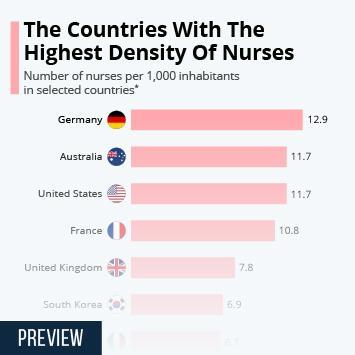Which country has the fifth highest density of Nurses per 1,000 inhabitants?
Answer the question with a short phrase. South Korea Which country has the highest density of Nurses per 1,000 inhabitants? Germany Which country share the second highest density of Nurses per 1,000 inhabitants along with United States? Australia Which country has the fourth highest density of Nurses per 1,000 inhabitants? United Kingdom Which two countries share the second highest density of Nurses per 1,000 inhabitants? Australia, United States Which country has the third highest density of Nurses per 1,000 inhabitants? France 